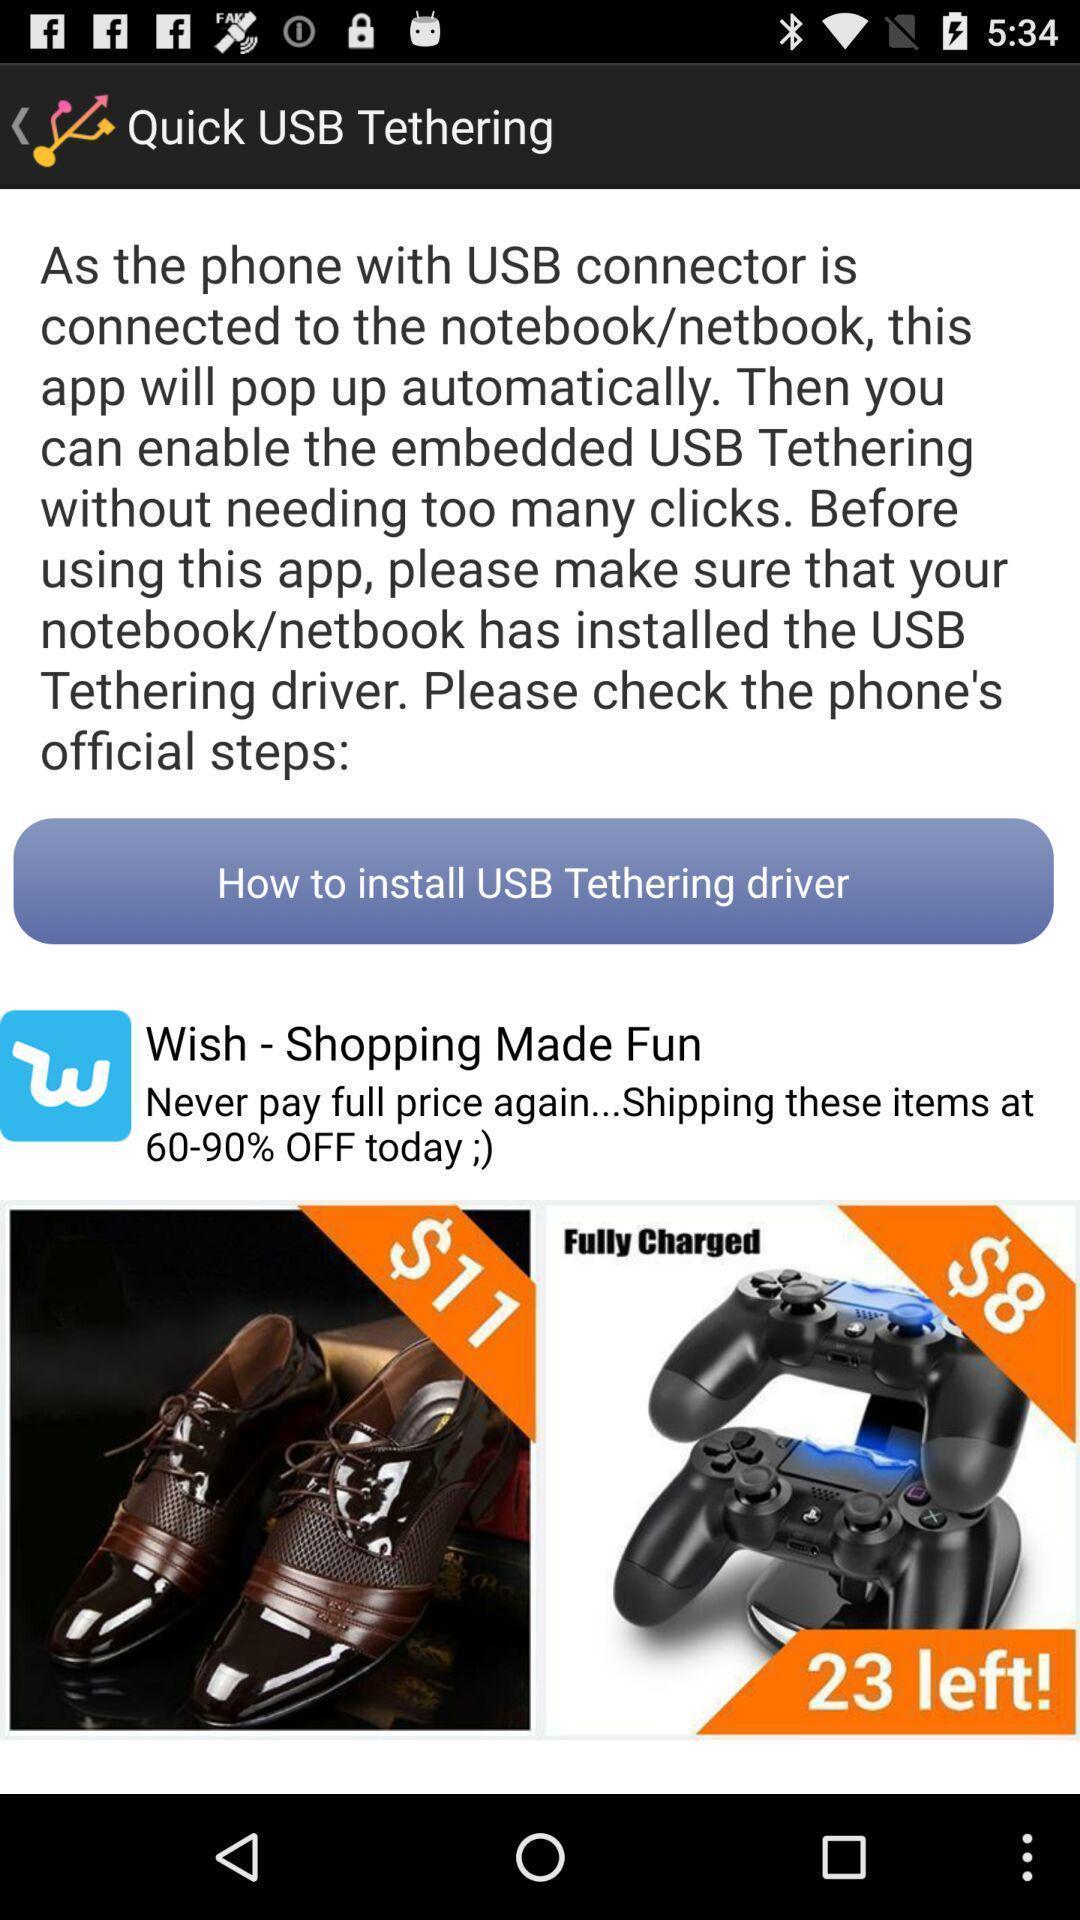Provide a description of this screenshot. Page showing information to install drive. 